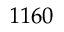Convert formula to latex. <formula><loc_0><loc_0><loc_500><loc_500>1 1 6 0</formula> 